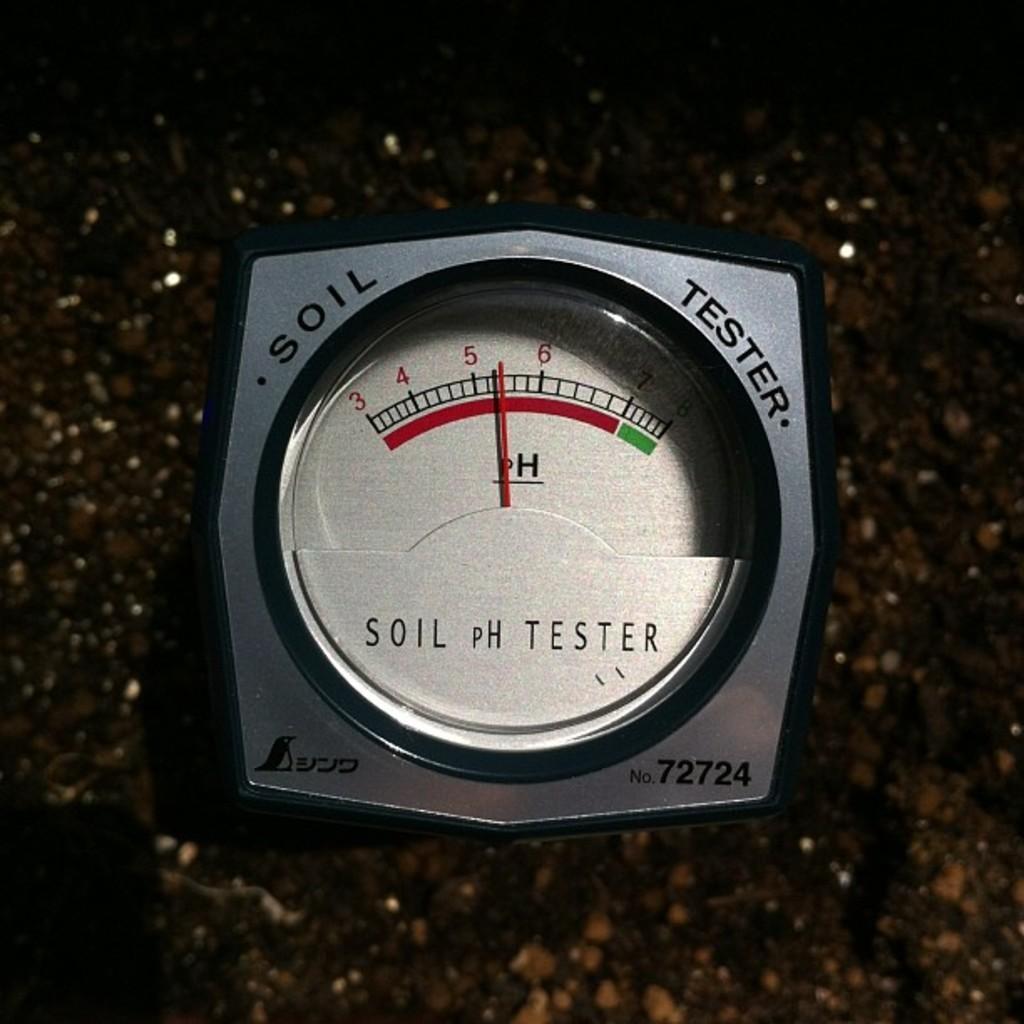How would you summarize this image in a sentence or two? In this picture there is a soil tester machine. At the bottom we can see the floor. 